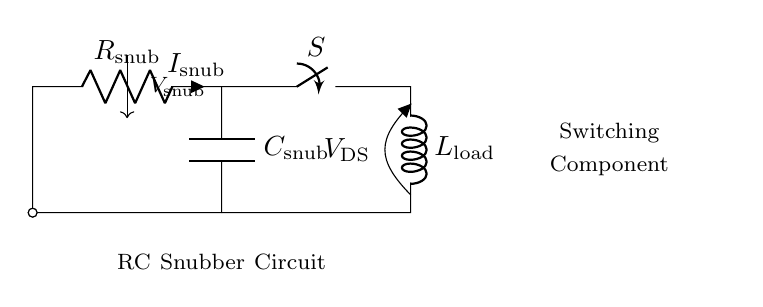What is the value assigned to the resistance in this circuit? The resistance in this circuit is labeled as R snub, indicating that it is the snubber resistor. There is no specific numerical value shown for resistance in this diagram, but it is represented by the label.
Answer: R snub What is the function of the capacitor in this circuit? The capacitor, labeled as C snub, functions to suppress voltage spikes, thus protecting the switching components from transients. This shows it plays a critical role in the snubbing process by absorbing high-frequency voltage spikes.
Answer: Suppression of voltage spikes What current flows through the resistor in this circuit? The current flowing through the resistor is labeled as I snub, which indicates the current specifically related to the snubber function of the resistor. It directly refers to the current passing through R snub during operation.
Answer: I snub How does this RC snubber circuit protect the switching component? The RC snubber circuit protects the switching component by minimizing the rate of voltage change and reducing electromagnetic interference. By having both resistance and capacitance, it dissipates energy and absorbs voltage spikes across the switch, ensuring ultimate longevity and reliability of the component.
Answer: Minimizes voltage change What type of load is connected in this circuit? The load connected in this circuit is labeled as L load, which represents an inductive load. This information is crucial as inductive loads are known to generate back EMF that can damage switching components.
Answer: L load What is the role of the switch in this snubber circuit? The switch, labeled as S, serves to control the circuit, allowing or interrupting the power flow to the load. It directly relates to the operation of the RC snubber by determining when the snubbing effect is necessary, thus managing the application of power to the load.
Answer: Control of power flow 